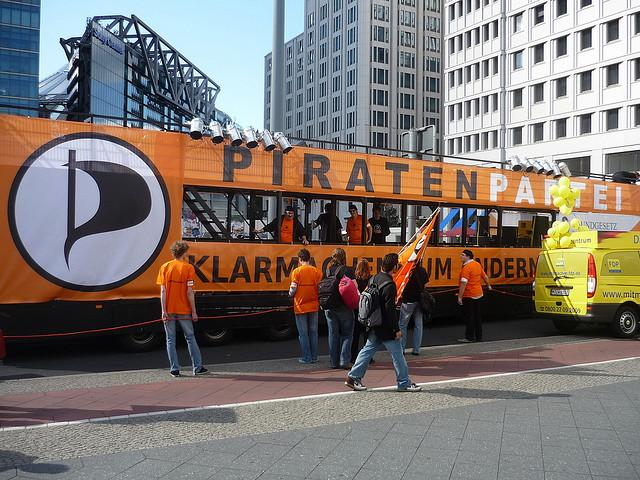Why are the people wearing orange shirts? Please explain your reasoning. uniform. It's their uniform so they all match. 